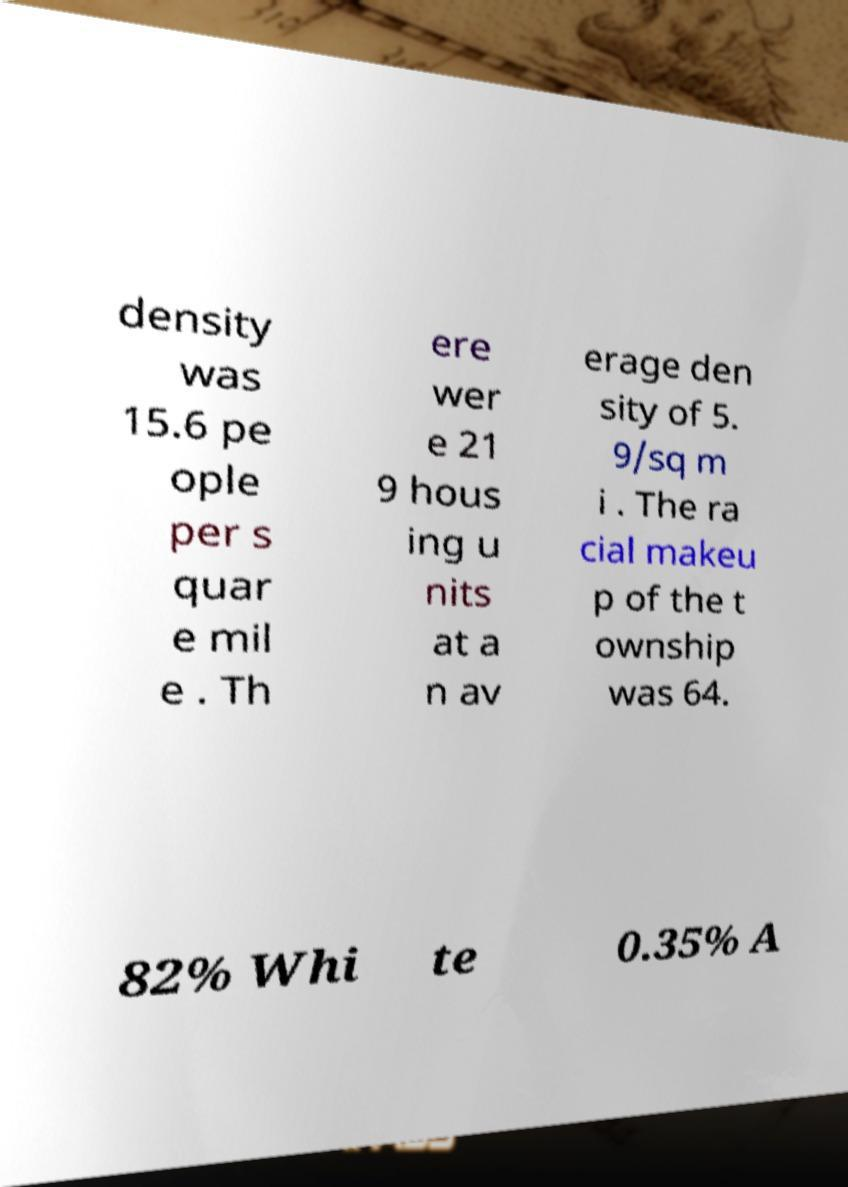Could you assist in decoding the text presented in this image and type it out clearly? density was 15.6 pe ople per s quar e mil e . Th ere wer e 21 9 hous ing u nits at a n av erage den sity of 5. 9/sq m i . The ra cial makeu p of the t ownship was 64. 82% Whi te 0.35% A 